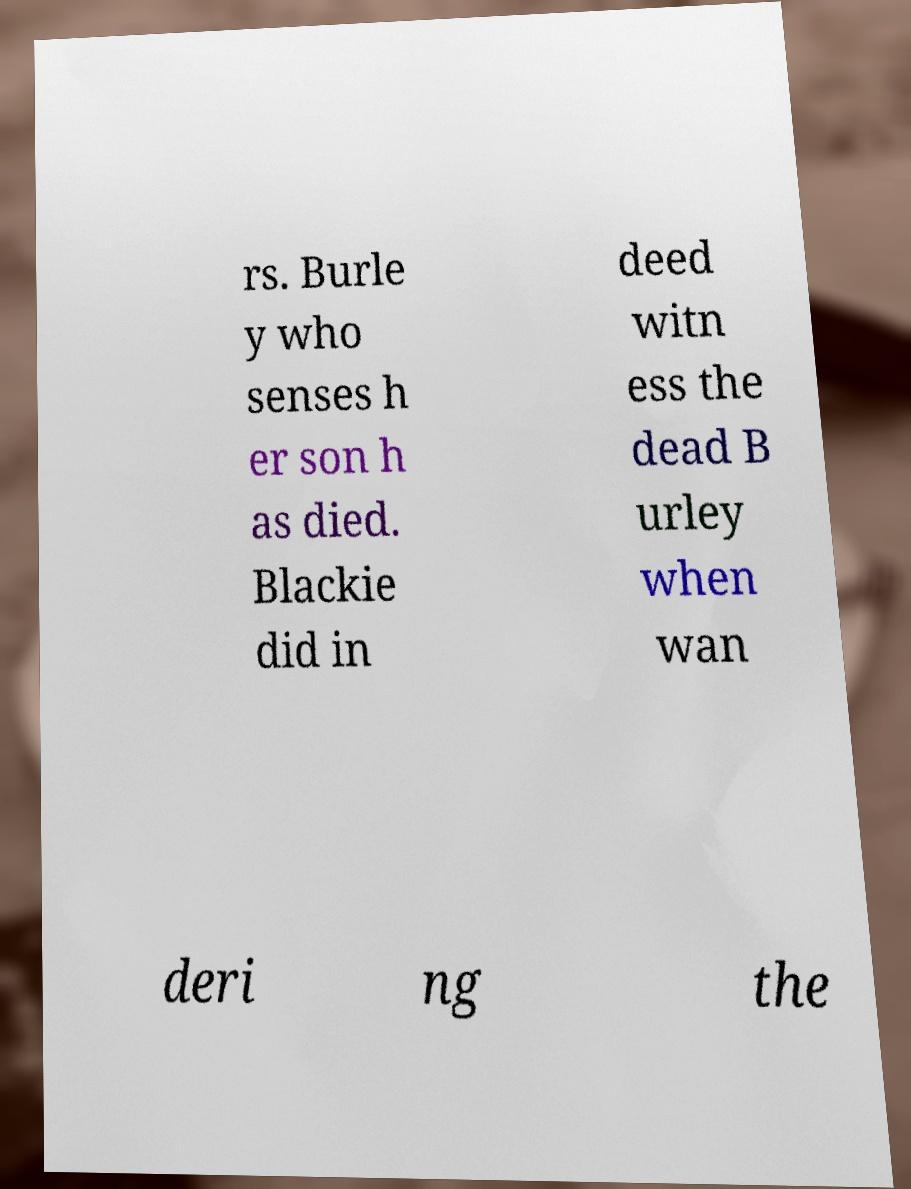There's text embedded in this image that I need extracted. Can you transcribe it verbatim? rs. Burle y who senses h er son h as died. Blackie did in deed witn ess the dead B urley when wan deri ng the 